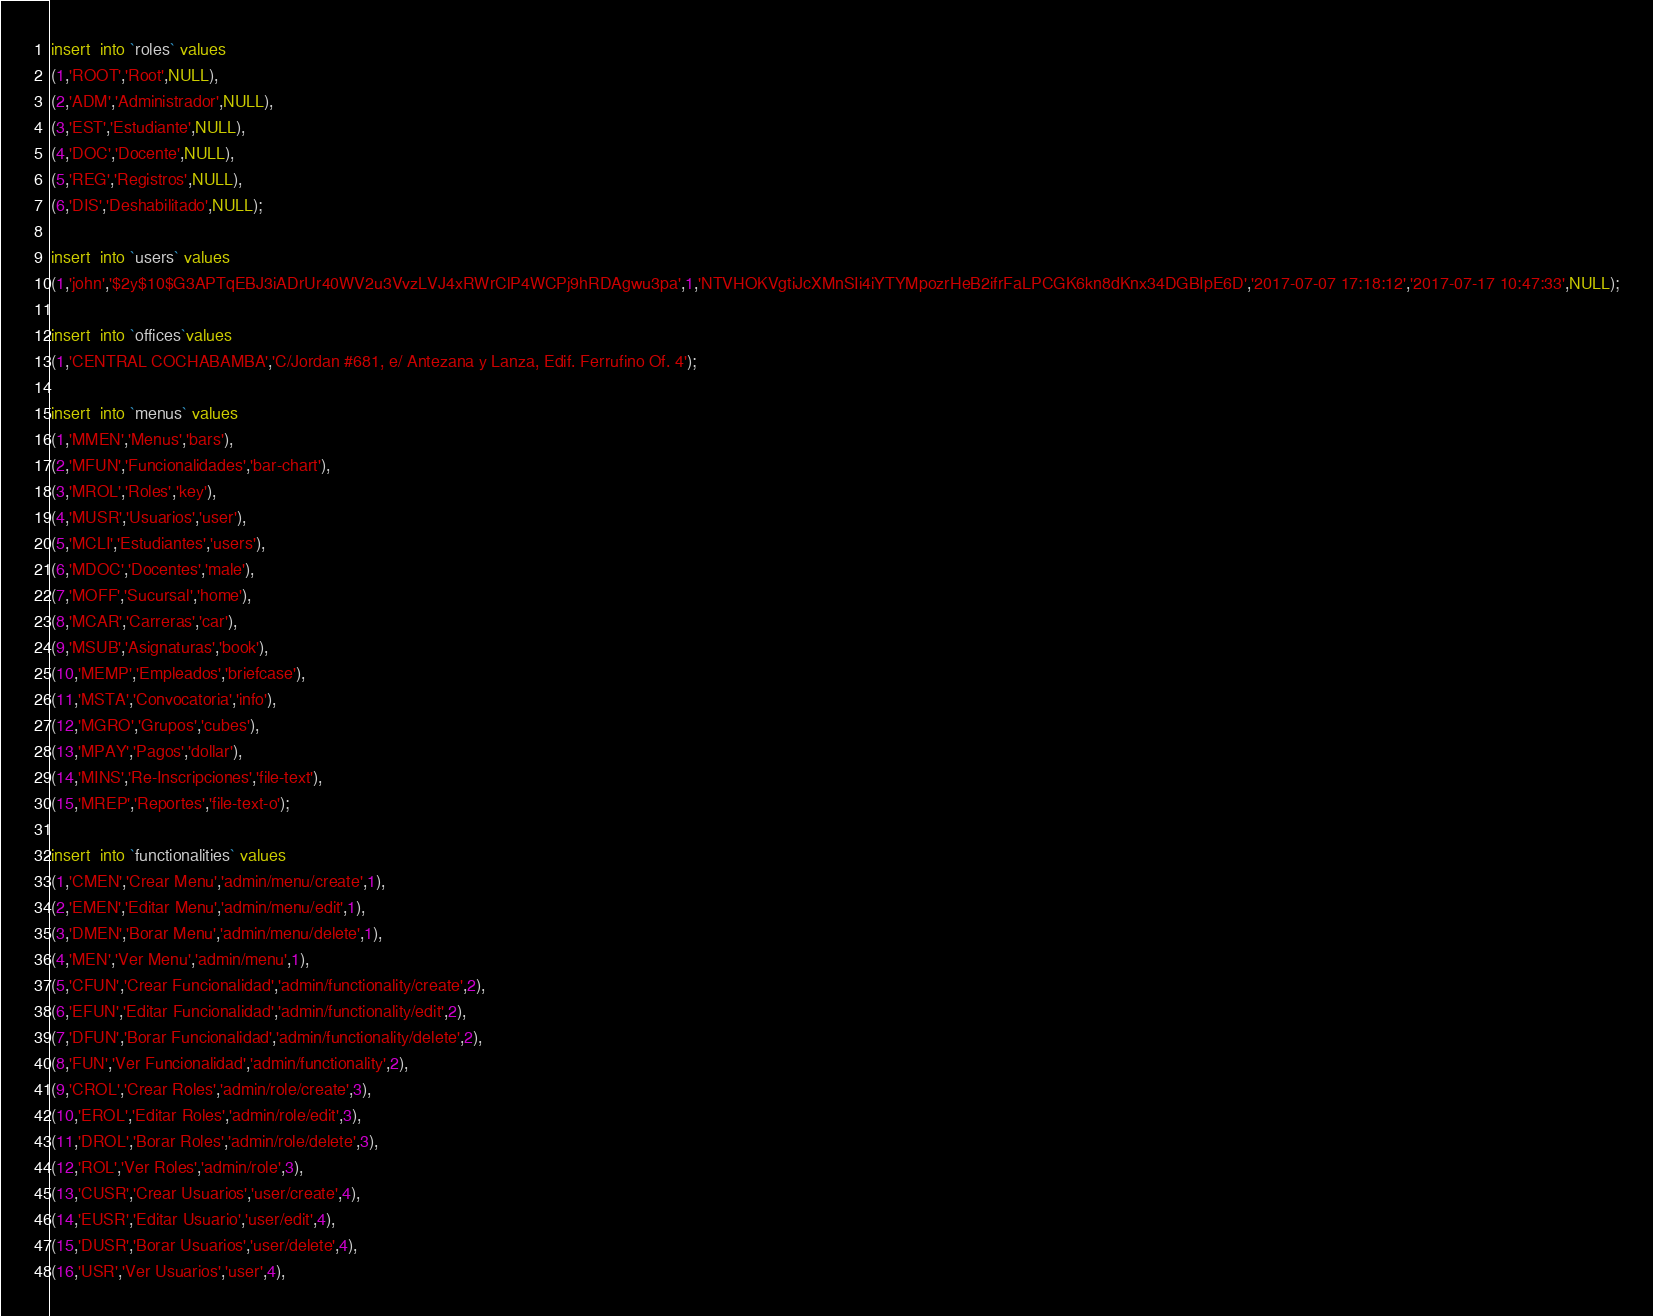Convert code to text. <code><loc_0><loc_0><loc_500><loc_500><_SQL_>
insert  into `roles` values 
(1,'ROOT','Root',NULL),
(2,'ADM','Administrador',NULL),
(3,'EST','Estudiante',NULL),
(4,'DOC','Docente',NULL),
(5,'REG','Registros',NULL),
(6,'DIS','Deshabilitado',NULL);

insert  into `users` values 
(1,'john','$2y$10$G3APTqEBJ3iADrUr40WV2u3VvzLVJ4xRWrClP4WCPj9hRDAgwu3pa',1,'NTVHOKVgtiJcXMnSIi4iYTYMpozrHeB2ifrFaLPCGK6kn8dKnx34DGBIpE6D','2017-07-07 17:18:12','2017-07-17 10:47:33',NULL);

insert  into `offices`values 
(1,'CENTRAL COCHABAMBA','C/Jordan #681, e/ Antezana y Lanza, Edif. Ferrufino Of. 4');

insert  into `menus` values 
(1,'MMEN','Menus','bars'),
(2,'MFUN','Funcionalidades','bar-chart'),
(3,'MROL','Roles','key'),
(4,'MUSR','Usuarios','user'),
(5,'MCLI','Estudiantes','users'),
(6,'MDOC','Docentes','male'),
(7,'MOFF','Sucursal','home'),
(8,'MCAR','Carreras','car'),
(9,'MSUB','Asignaturas','book'),
(10,'MEMP','Empleados','briefcase'),
(11,'MSTA','Convocatoria','info'),
(12,'MGRO','Grupos','cubes'),
(13,'MPAY','Pagos','dollar'),
(14,'MINS','Re-Inscripciones','file-text'),
(15,'MREP','Reportes','file-text-o');

insert  into `functionalities` values 
(1,'CMEN','Crear Menu','admin/menu/create',1),
(2,'EMEN','Editar Menu','admin/menu/edit',1),
(3,'DMEN','Borar Menu','admin/menu/delete',1),
(4,'MEN','Ver Menu','admin/menu',1),
(5,'CFUN','Crear Funcionalidad','admin/functionality/create',2),
(6,'EFUN','Editar Funcionalidad','admin/functionality/edit',2),
(7,'DFUN','Borar Funcionalidad','admin/functionality/delete',2),
(8,'FUN','Ver Funcionalidad','admin/functionality',2),
(9,'CROL','Crear Roles','admin/role/create',3),
(10,'EROL','Editar Roles','admin/role/edit',3),
(11,'DROL','Borar Roles','admin/role/delete',3),
(12,'ROL','Ver Roles','admin/role',3),
(13,'CUSR','Crear Usuarios','user/create',4),
(14,'EUSR','Editar Usuario','user/edit',4),
(15,'DUSR','Borar Usuarios','user/delete',4),
(16,'USR','Ver Usuarios','user',4),</code> 